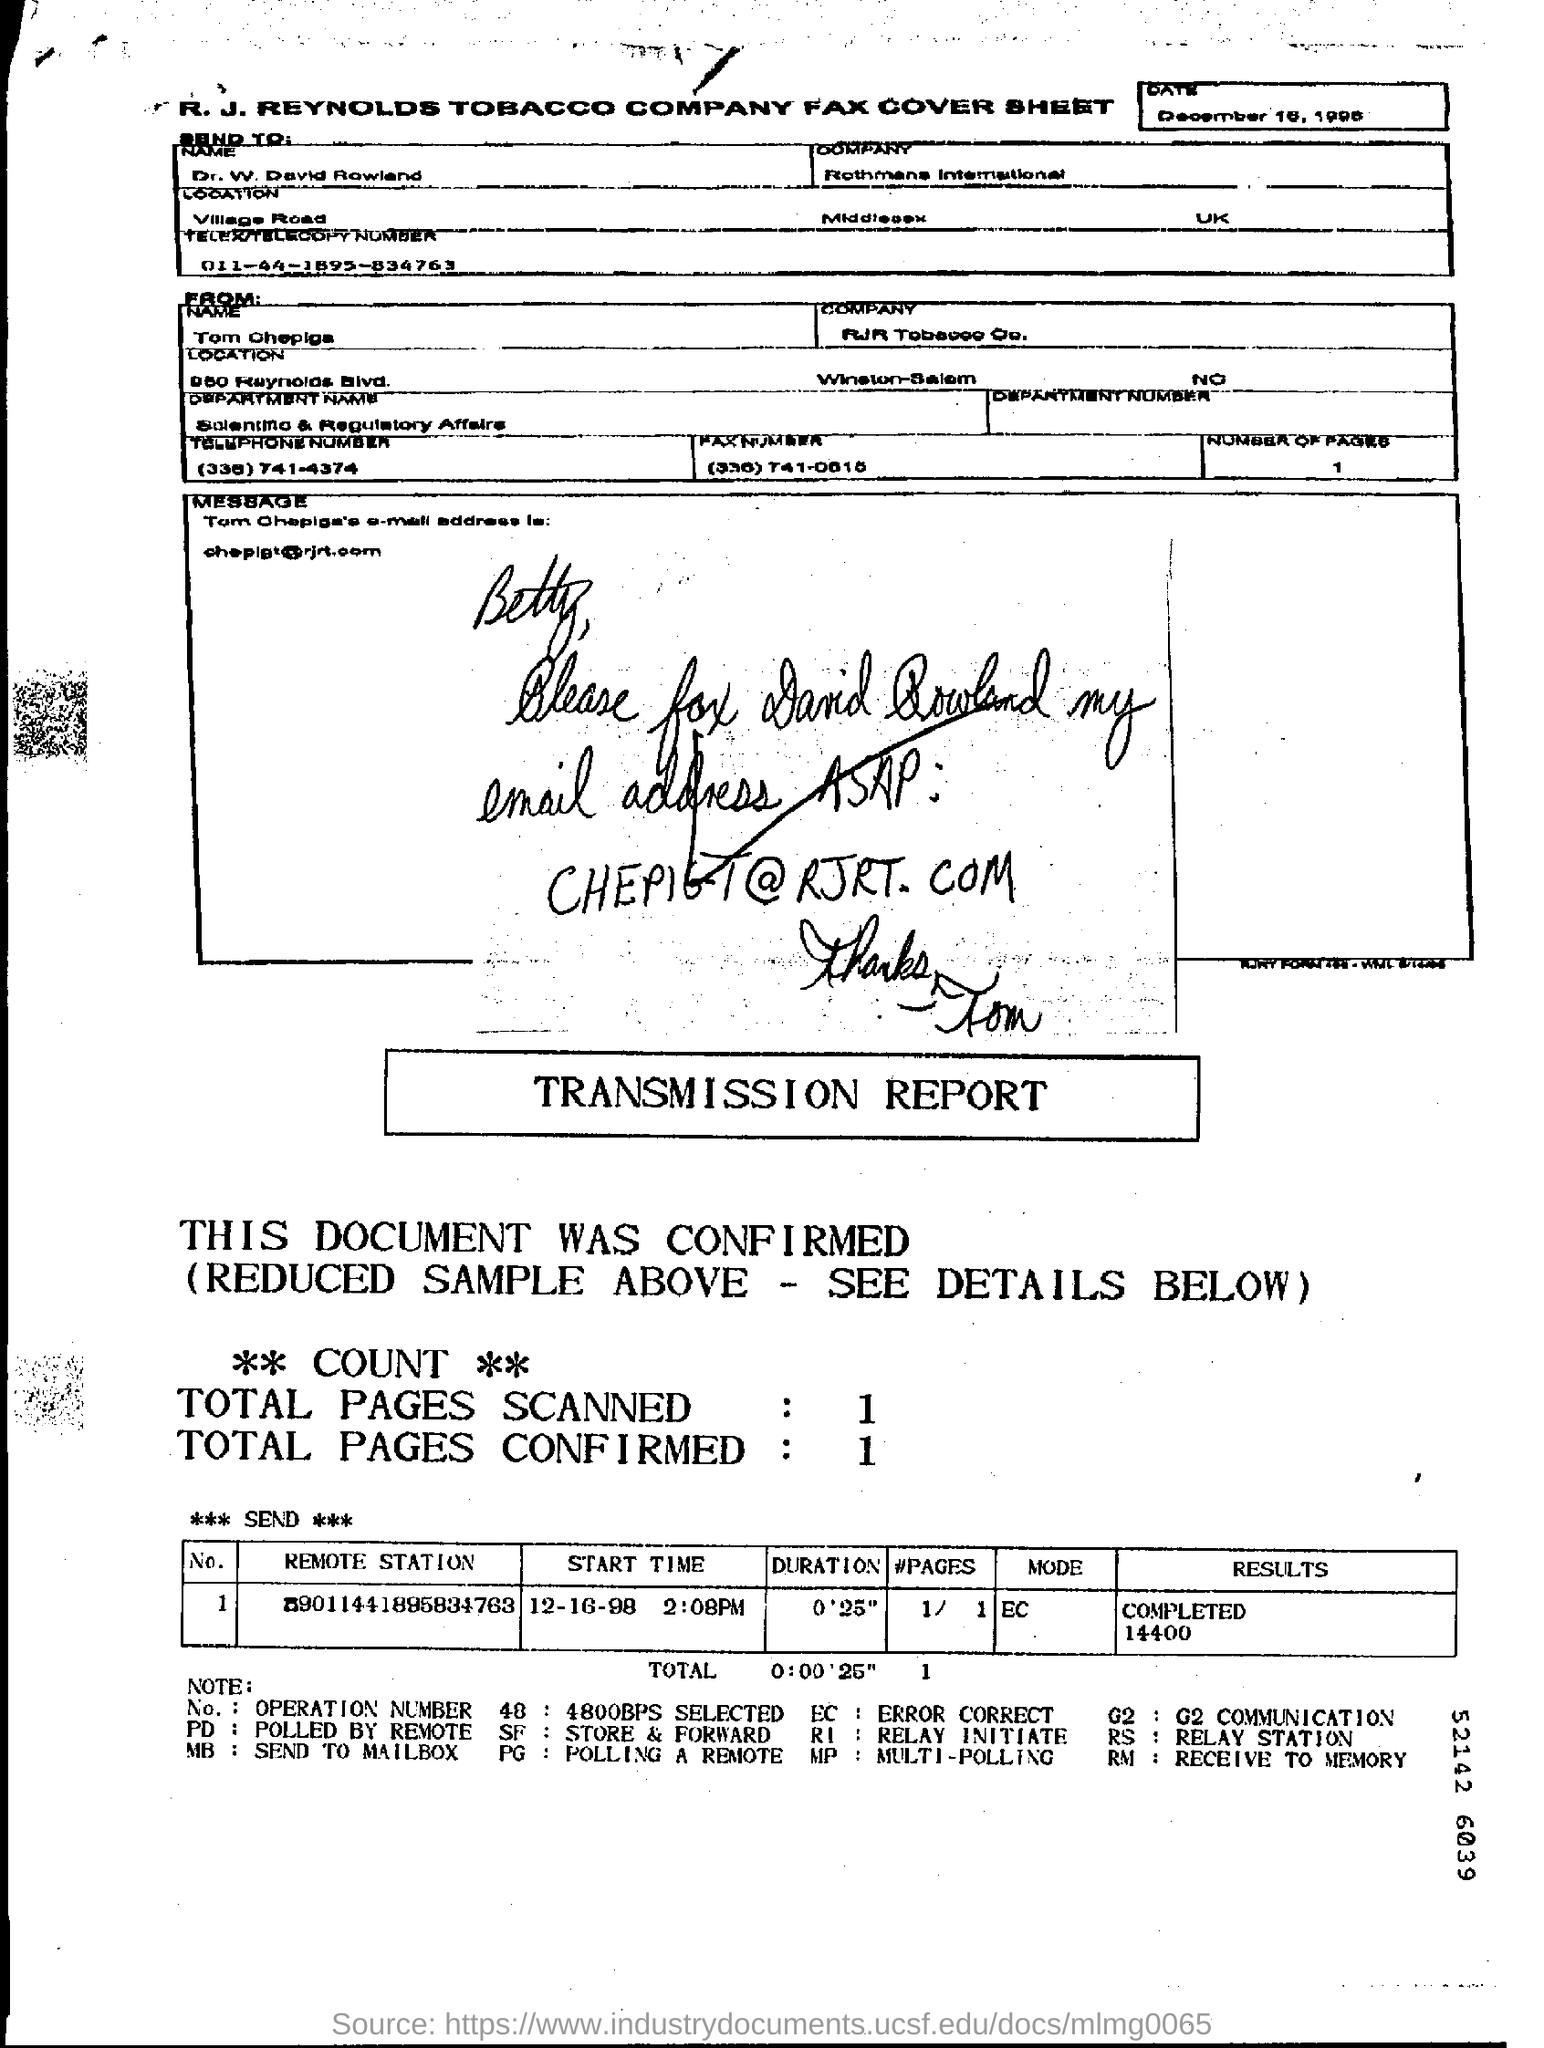Draw attention to some important aspects in this diagram. What is the Send To "Name"? This is a question asked by Dr. W. David Rowland. The total number of pages confirmed is 1.. Rothmans International is the company that is associated with the sender. What is the duration? It is 0'25". The total number of pages scanned is 1.. 